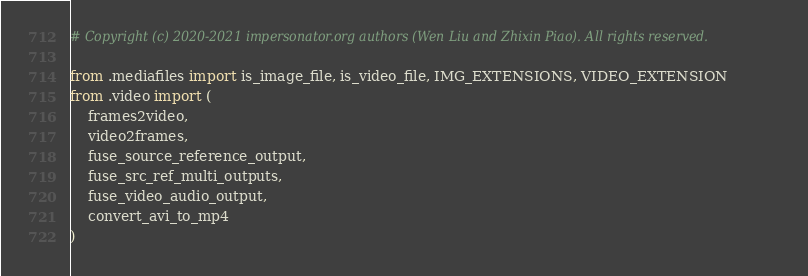<code> <loc_0><loc_0><loc_500><loc_500><_Python_># Copyright (c) 2020-2021 impersonator.org authors (Wen Liu and Zhixin Piao). All rights reserved.

from .mediafiles import is_image_file, is_video_file, IMG_EXTENSIONS, VIDEO_EXTENSION
from .video import (
    frames2video,
    video2frames,
    fuse_source_reference_output,
    fuse_src_ref_multi_outputs,
    fuse_video_audio_output,
    convert_avi_to_mp4
)


</code> 